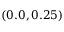Convert formula to latex. <formula><loc_0><loc_0><loc_500><loc_500>( 0 . 0 , 0 . 2 5 )</formula> 